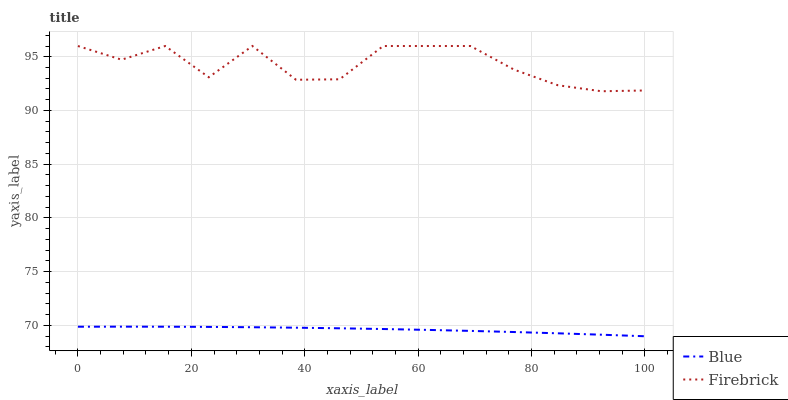Does Blue have the minimum area under the curve?
Answer yes or no. Yes. Does Firebrick have the maximum area under the curve?
Answer yes or no. Yes. Does Firebrick have the minimum area under the curve?
Answer yes or no. No. Is Blue the smoothest?
Answer yes or no. Yes. Is Firebrick the roughest?
Answer yes or no. Yes. Is Firebrick the smoothest?
Answer yes or no. No. Does Firebrick have the lowest value?
Answer yes or no. No. Is Blue less than Firebrick?
Answer yes or no. Yes. Is Firebrick greater than Blue?
Answer yes or no. Yes. Does Blue intersect Firebrick?
Answer yes or no. No. 